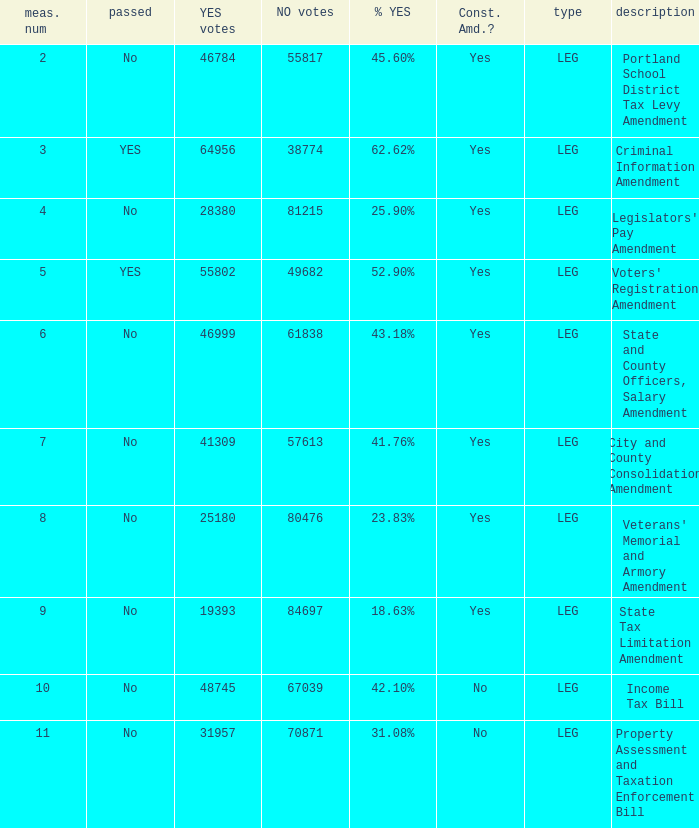Could you help me parse every detail presented in this table? {'header': ['meas. num', 'passed', 'YES votes', 'NO votes', '% YES', 'Const. Amd.?', 'type', 'description'], 'rows': [['2', 'No', '46784', '55817', '45.60%', 'Yes', 'LEG', 'Portland School District Tax Levy Amendment'], ['3', 'YES', '64956', '38774', '62.62%', 'Yes', 'LEG', 'Criminal Information Amendment'], ['4', 'No', '28380', '81215', '25.90%', 'Yes', 'LEG', "Legislators' Pay Amendment"], ['5', 'YES', '55802', '49682', '52.90%', 'Yes', 'LEG', "Voters' Registration Amendment"], ['6', 'No', '46999', '61838', '43.18%', 'Yes', 'LEG', 'State and County Officers, Salary Amendment'], ['7', 'No', '41309', '57613', '41.76%', 'Yes', 'LEG', 'City and County Consolidation Amendment'], ['8', 'No', '25180', '80476', '23.83%', 'Yes', 'LEG', "Veterans' Memorial and Armory Amendment"], ['9', 'No', '19393', '84697', '18.63%', 'Yes', 'LEG', 'State Tax Limitation Amendment'], ['10', 'No', '48745', '67039', '42.10%', 'No', 'LEG', 'Income Tax Bill'], ['11', 'No', '31957', '70871', '31.08%', 'No', 'LEG', 'Property Assessment and Taxation Enforcement Bill']]} How many affirmative votes constituted 4 46999.0. 